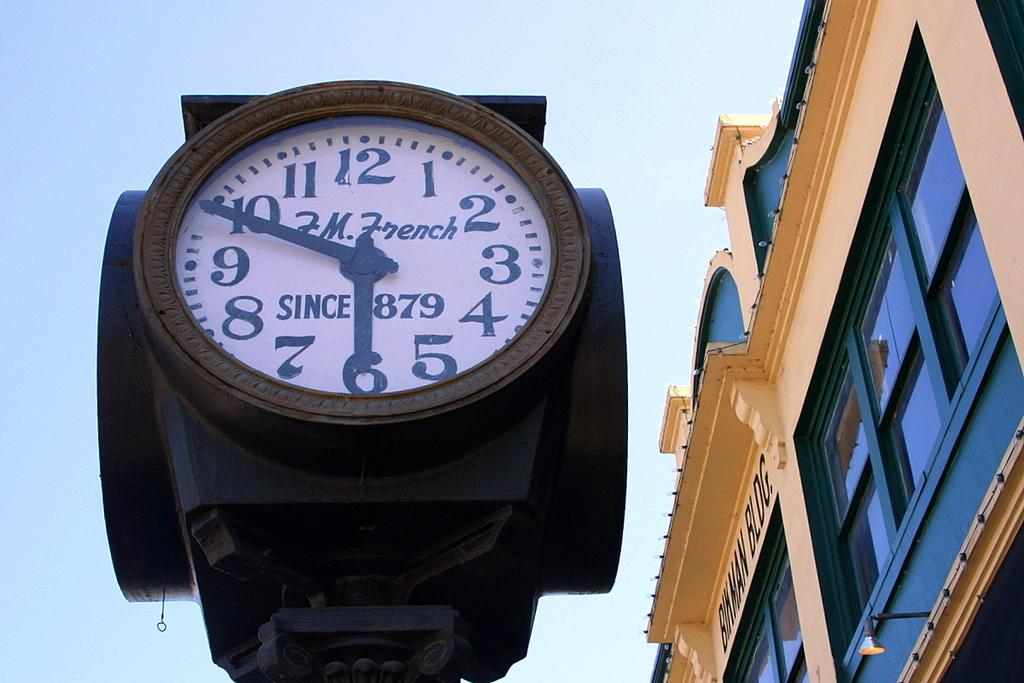<image>
Offer a succinct explanation of the picture presented. A tower clock with F.M. French on its face. 